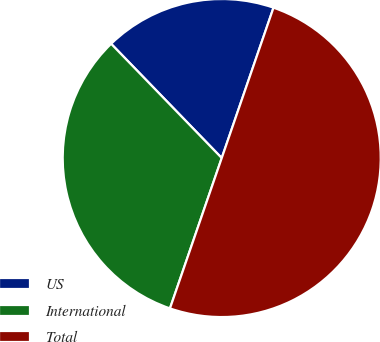Convert chart. <chart><loc_0><loc_0><loc_500><loc_500><pie_chart><fcel>US<fcel>International<fcel>Total<nl><fcel>17.52%<fcel>32.48%<fcel>50.0%<nl></chart> 